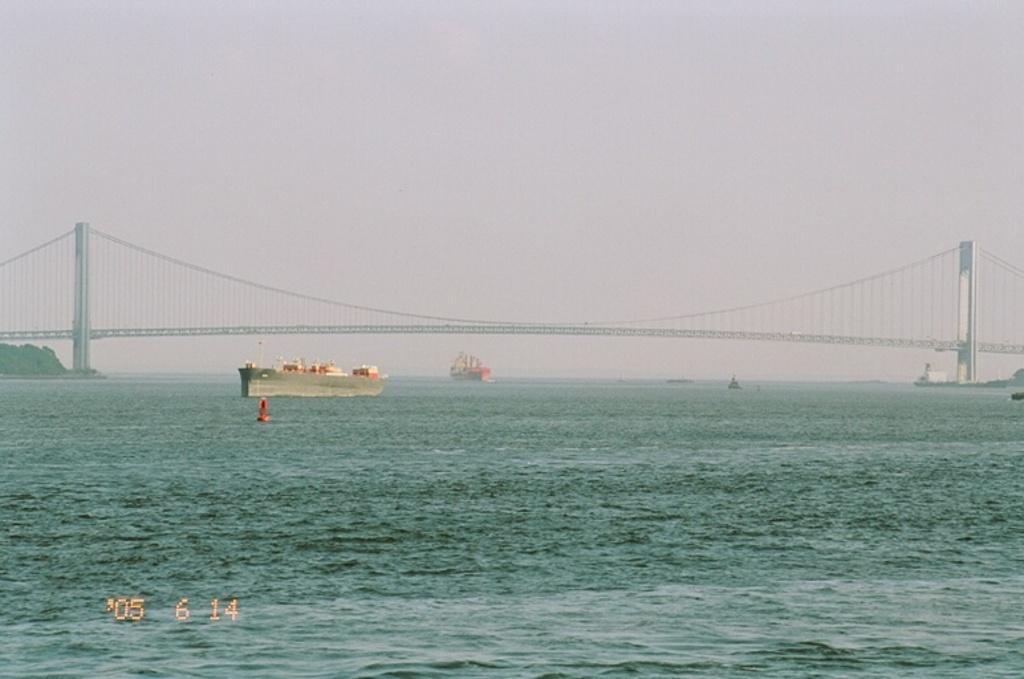Describe this image in one or two sentences. In the image there are ships on the water. There is a bridge above the water. And also there are pillars in the water. On the left side of the image there are trees. At the top of the image there is sky. 